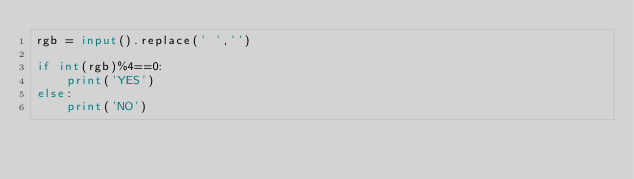<code> <loc_0><loc_0><loc_500><loc_500><_Python_>rgb = input().replace(' ','')

if int(rgb)%4==0:
    print('YES')
else:
    print('NO')</code> 